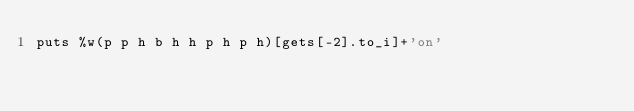Convert code to text. <code><loc_0><loc_0><loc_500><loc_500><_Ruby_>puts %w(p p h b h h p h p h)[gets[-2].to_i]+'on'
</code> 